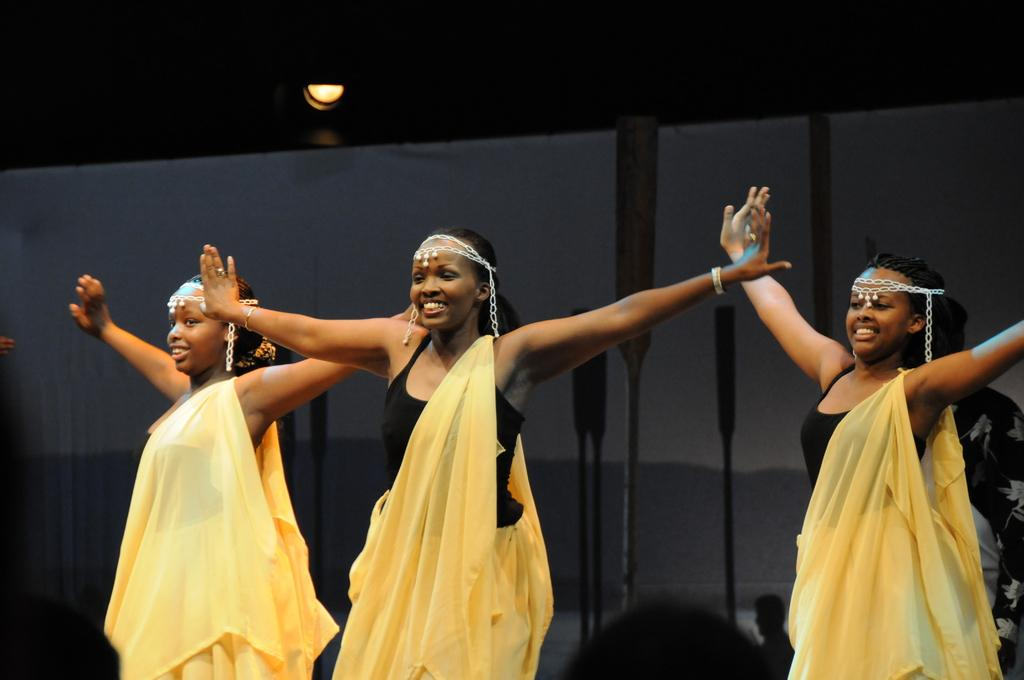Who is present in the image? There are girls in the image. What are the girls doing in the image? The girls are dancing. What type of pin can be seen holding the girls' hair in the image? There is no pin visible in the image; the girls' hair is not mentioned in the provided facts. 